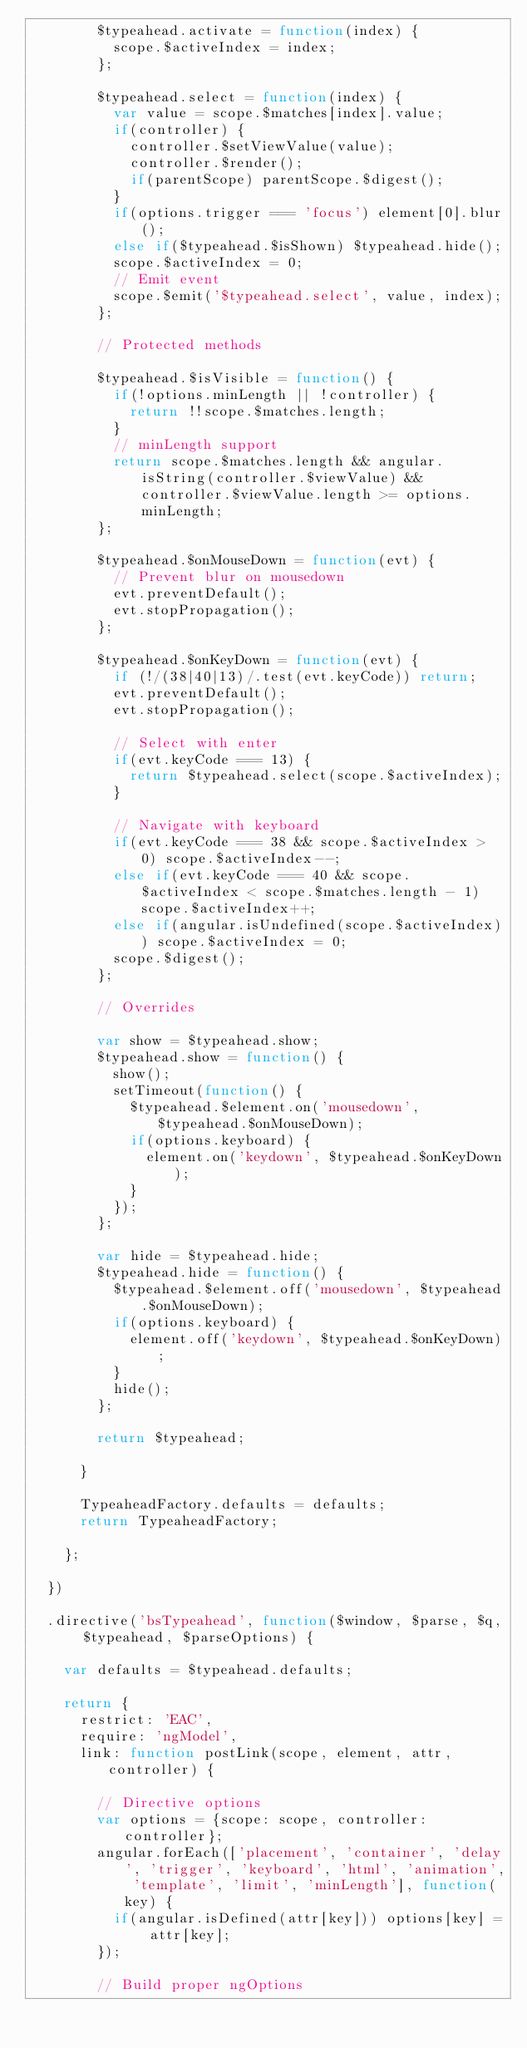<code> <loc_0><loc_0><loc_500><loc_500><_JavaScript_>        $typeahead.activate = function(index) {
          scope.$activeIndex = index;
        };

        $typeahead.select = function(index) {
          var value = scope.$matches[index].value;
          if(controller) {
            controller.$setViewValue(value);
            controller.$render();
            if(parentScope) parentScope.$digest();
          }
          if(options.trigger === 'focus') element[0].blur();
          else if($typeahead.$isShown) $typeahead.hide();
          scope.$activeIndex = 0;
          // Emit event
          scope.$emit('$typeahead.select', value, index);
        };

        // Protected methods

        $typeahead.$isVisible = function() {
          if(!options.minLength || !controller) {
            return !!scope.$matches.length;
          }
          // minLength support
          return scope.$matches.length && angular.isString(controller.$viewValue) && controller.$viewValue.length >= options.minLength;
        };

        $typeahead.$onMouseDown = function(evt) {
          // Prevent blur on mousedown
          evt.preventDefault();
          evt.stopPropagation();
        };

        $typeahead.$onKeyDown = function(evt) {
          if (!/(38|40|13)/.test(evt.keyCode)) return;
          evt.preventDefault();
          evt.stopPropagation();

          // Select with enter
          if(evt.keyCode === 13) {
            return $typeahead.select(scope.$activeIndex);
          }

          // Navigate with keyboard
          if(evt.keyCode === 38 && scope.$activeIndex > 0) scope.$activeIndex--;
          else if(evt.keyCode === 40 && scope.$activeIndex < scope.$matches.length - 1) scope.$activeIndex++;
          else if(angular.isUndefined(scope.$activeIndex)) scope.$activeIndex = 0;
          scope.$digest();
        };

        // Overrides

        var show = $typeahead.show;
        $typeahead.show = function() {
          show();
          setTimeout(function() {
            $typeahead.$element.on('mousedown', $typeahead.$onMouseDown);
            if(options.keyboard) {
              element.on('keydown', $typeahead.$onKeyDown);
            }
          });
        };

        var hide = $typeahead.hide;
        $typeahead.hide = function() {
          $typeahead.$element.off('mousedown', $typeahead.$onMouseDown);
          if(options.keyboard) {
            element.off('keydown', $typeahead.$onKeyDown);
          }
          hide();
        };

        return $typeahead;

      }

      TypeaheadFactory.defaults = defaults;
      return TypeaheadFactory;

    };

  })

  .directive('bsTypeahead', function($window, $parse, $q, $typeahead, $parseOptions) {

    var defaults = $typeahead.defaults;

    return {
      restrict: 'EAC',
      require: 'ngModel',
      link: function postLink(scope, element, attr, controller) {

        // Directive options
        var options = {scope: scope, controller: controller};
        angular.forEach(['placement', 'container', 'delay', 'trigger', 'keyboard', 'html', 'animation', 'template', 'limit', 'minLength'], function(key) {
          if(angular.isDefined(attr[key])) options[key] = attr[key];
        });

        // Build proper ngOptions</code> 